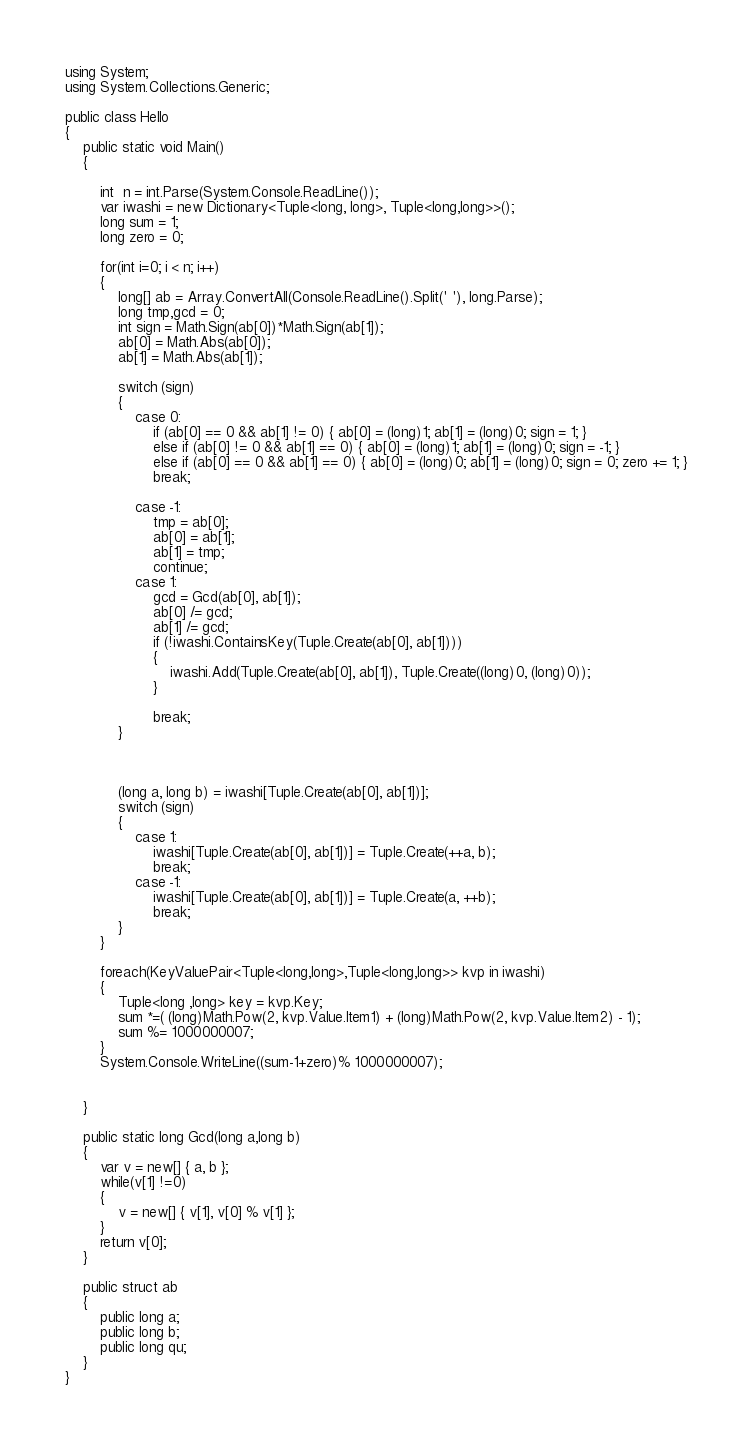Convert code to text. <code><loc_0><loc_0><loc_500><loc_500><_C#_>using System;
using System.Collections.Generic;

public class Hello
{
    public static void Main()
    {

        int  n = int.Parse(System.Console.ReadLine());
        var iwashi = new Dictionary<Tuple<long, long>, Tuple<long,long>>();
        long sum = 1;
        long zero = 0;

        for(int i=0; i < n; i++)
        {
            long[] ab = Array.ConvertAll(Console.ReadLine().Split(' '), long.Parse);
            long tmp,gcd = 0;
            int sign = Math.Sign(ab[0])*Math.Sign(ab[1]);
            ab[0] = Math.Abs(ab[0]);
            ab[1] = Math.Abs(ab[1]);
            
            switch (sign)
            {
                case 0:
                    if (ab[0] == 0 && ab[1] != 0) { ab[0] = (long)1; ab[1] = (long)0; sign = 1; }
                    else if (ab[0] != 0 && ab[1] == 0) { ab[0] = (long)1; ab[1] = (long)0; sign = -1; }
                    else if (ab[0] == 0 && ab[1] == 0) { ab[0] = (long)0; ab[1] = (long)0; sign = 0; zero += 1; }
                    break;

                case -1:
                    tmp = ab[0];
                    ab[0] = ab[1];
                    ab[1] = tmp;
                    continue;
                case 1:
                    gcd = Gcd(ab[0], ab[1]);
                    ab[0] /= gcd;
                    ab[1] /= gcd;
                    if (!iwashi.ContainsKey(Tuple.Create(ab[0], ab[1])))
                    {
                        iwashi.Add(Tuple.Create(ab[0], ab[1]), Tuple.Create((long)0, (long)0));
                    }
                    
                    break;
            }



            (long a, long b) = iwashi[Tuple.Create(ab[0], ab[1])];
            switch (sign)
            {
                case 1:
                    iwashi[Tuple.Create(ab[0], ab[1])] = Tuple.Create(++a, b);
                    break;
                case -1:
                    iwashi[Tuple.Create(ab[0], ab[1])] = Tuple.Create(a, ++b);
                    break;
            }
        }
        
        foreach(KeyValuePair<Tuple<long,long>,Tuple<long,long>> kvp in iwashi)
        {
            Tuple<long ,long> key = kvp.Key;
            sum *=( (long)Math.Pow(2, kvp.Value.Item1) + (long)Math.Pow(2, kvp.Value.Item2) - 1);
            sum %= 1000000007;
        }
        System.Console.WriteLine((sum-1+zero)% 1000000007);


    }

    public static long Gcd(long a,long b)
    {
        var v = new[] { a, b };
        while(v[1] !=0)
        {
            v = new[] { v[1], v[0] % v[1] };
        }
        return v[0];
    }

    public struct ab
    {
        public long a;
        public long b;
        public long qu;
    }
}</code> 